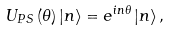Convert formula to latex. <formula><loc_0><loc_0><loc_500><loc_500>U _ { P S } \left ( \theta \right ) \left | n \right \rangle = e ^ { i n \theta } \left | n \right \rangle ,</formula> 